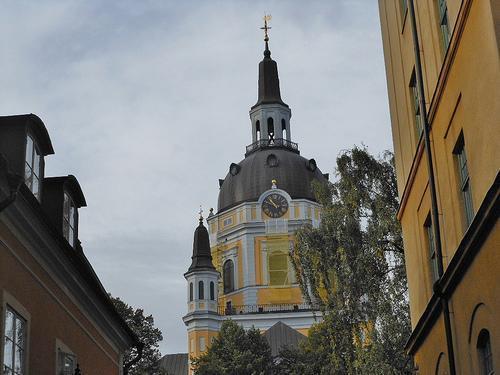How many clocks are in this picture?
Give a very brief answer. 1. 